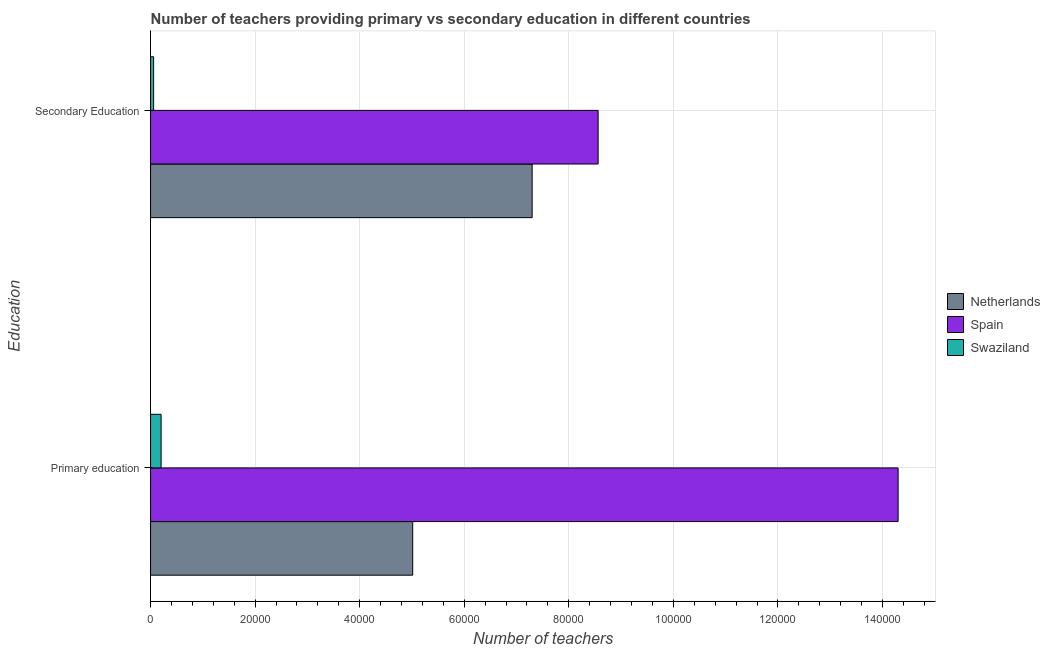How many groups of bars are there?
Provide a succinct answer. 2. Are the number of bars per tick equal to the number of legend labels?
Keep it short and to the point. Yes. How many bars are there on the 1st tick from the top?
Give a very brief answer. 3. What is the number of primary teachers in Swaziland?
Make the answer very short. 2015. Across all countries, what is the maximum number of secondary teachers?
Offer a terse response. 8.56e+04. Across all countries, what is the minimum number of secondary teachers?
Provide a succinct answer. 586. In which country was the number of secondary teachers maximum?
Make the answer very short. Spain. In which country was the number of primary teachers minimum?
Keep it short and to the point. Swaziland. What is the total number of primary teachers in the graph?
Provide a succinct answer. 1.95e+05. What is the difference between the number of secondary teachers in Swaziland and that in Netherlands?
Offer a very short reply. -7.24e+04. What is the difference between the number of primary teachers in Swaziland and the number of secondary teachers in Spain?
Ensure brevity in your answer.  -8.36e+04. What is the average number of primary teachers per country?
Your answer should be compact. 6.50e+04. What is the difference between the number of secondary teachers and number of primary teachers in Swaziland?
Your answer should be very brief. -1429. What is the ratio of the number of primary teachers in Spain to that in Swaziland?
Give a very brief answer. 70.96. Is the number of primary teachers in Swaziland less than that in Spain?
Your answer should be compact. Yes. What does the 3rd bar from the top in Secondary Education represents?
Make the answer very short. Netherlands. What does the 2nd bar from the bottom in Secondary Education represents?
Your answer should be very brief. Spain. How many bars are there?
Your answer should be very brief. 6. Are all the bars in the graph horizontal?
Offer a very short reply. Yes. How many countries are there in the graph?
Keep it short and to the point. 3. What is the difference between two consecutive major ticks on the X-axis?
Keep it short and to the point. 2.00e+04. Are the values on the major ticks of X-axis written in scientific E-notation?
Provide a short and direct response. No. Where does the legend appear in the graph?
Keep it short and to the point. Center right. What is the title of the graph?
Make the answer very short. Number of teachers providing primary vs secondary education in different countries. What is the label or title of the X-axis?
Provide a short and direct response. Number of teachers. What is the label or title of the Y-axis?
Ensure brevity in your answer.  Education. What is the Number of teachers of Netherlands in Primary education?
Your answer should be compact. 5.01e+04. What is the Number of teachers in Spain in Primary education?
Provide a succinct answer. 1.43e+05. What is the Number of teachers in Swaziland in Primary education?
Your answer should be compact. 2015. What is the Number of teachers in Netherlands in Secondary Education?
Offer a terse response. 7.30e+04. What is the Number of teachers of Spain in Secondary Education?
Give a very brief answer. 8.56e+04. What is the Number of teachers of Swaziland in Secondary Education?
Your answer should be very brief. 586. Across all Education, what is the maximum Number of teachers of Netherlands?
Provide a succinct answer. 7.30e+04. Across all Education, what is the maximum Number of teachers of Spain?
Offer a very short reply. 1.43e+05. Across all Education, what is the maximum Number of teachers of Swaziland?
Give a very brief answer. 2015. Across all Education, what is the minimum Number of teachers in Netherlands?
Offer a terse response. 5.01e+04. Across all Education, what is the minimum Number of teachers of Spain?
Offer a terse response. 8.56e+04. Across all Education, what is the minimum Number of teachers in Swaziland?
Provide a succinct answer. 586. What is the total Number of teachers of Netherlands in the graph?
Offer a very short reply. 1.23e+05. What is the total Number of teachers of Spain in the graph?
Ensure brevity in your answer.  2.29e+05. What is the total Number of teachers in Swaziland in the graph?
Make the answer very short. 2601. What is the difference between the Number of teachers in Netherlands in Primary education and that in Secondary Education?
Keep it short and to the point. -2.28e+04. What is the difference between the Number of teachers of Spain in Primary education and that in Secondary Education?
Your answer should be very brief. 5.74e+04. What is the difference between the Number of teachers in Swaziland in Primary education and that in Secondary Education?
Offer a terse response. 1429. What is the difference between the Number of teachers in Netherlands in Primary education and the Number of teachers in Spain in Secondary Education?
Offer a terse response. -3.55e+04. What is the difference between the Number of teachers of Netherlands in Primary education and the Number of teachers of Swaziland in Secondary Education?
Provide a succinct answer. 4.96e+04. What is the difference between the Number of teachers of Spain in Primary education and the Number of teachers of Swaziland in Secondary Education?
Give a very brief answer. 1.42e+05. What is the average Number of teachers in Netherlands per Education?
Offer a terse response. 6.16e+04. What is the average Number of teachers of Spain per Education?
Provide a succinct answer. 1.14e+05. What is the average Number of teachers in Swaziland per Education?
Your answer should be compact. 1300.5. What is the difference between the Number of teachers in Netherlands and Number of teachers in Spain in Primary education?
Your answer should be very brief. -9.28e+04. What is the difference between the Number of teachers in Netherlands and Number of teachers in Swaziland in Primary education?
Ensure brevity in your answer.  4.81e+04. What is the difference between the Number of teachers in Spain and Number of teachers in Swaziland in Primary education?
Your response must be concise. 1.41e+05. What is the difference between the Number of teachers of Netherlands and Number of teachers of Spain in Secondary Education?
Ensure brevity in your answer.  -1.26e+04. What is the difference between the Number of teachers of Netherlands and Number of teachers of Swaziland in Secondary Education?
Your response must be concise. 7.24e+04. What is the difference between the Number of teachers of Spain and Number of teachers of Swaziland in Secondary Education?
Provide a short and direct response. 8.50e+04. What is the ratio of the Number of teachers in Netherlands in Primary education to that in Secondary Education?
Your response must be concise. 0.69. What is the ratio of the Number of teachers in Spain in Primary education to that in Secondary Education?
Offer a very short reply. 1.67. What is the ratio of the Number of teachers of Swaziland in Primary education to that in Secondary Education?
Give a very brief answer. 3.44. What is the difference between the highest and the second highest Number of teachers of Netherlands?
Keep it short and to the point. 2.28e+04. What is the difference between the highest and the second highest Number of teachers of Spain?
Keep it short and to the point. 5.74e+04. What is the difference between the highest and the second highest Number of teachers of Swaziland?
Your answer should be compact. 1429. What is the difference between the highest and the lowest Number of teachers of Netherlands?
Your answer should be very brief. 2.28e+04. What is the difference between the highest and the lowest Number of teachers in Spain?
Provide a succinct answer. 5.74e+04. What is the difference between the highest and the lowest Number of teachers in Swaziland?
Offer a very short reply. 1429. 